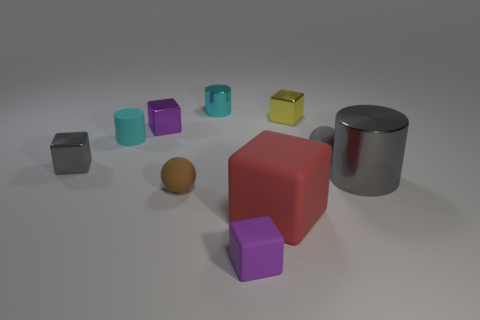Subtract all small cyan cylinders. How many cylinders are left? 1 Subtract all gray spheres. How many spheres are left? 1 Subtract all cylinders. How many objects are left? 7 Subtract 2 cylinders. How many cylinders are left? 1 Subtract 0 green balls. How many objects are left? 10 Subtract all brown spheres. Subtract all gray cylinders. How many spheres are left? 1 Subtract all cyan balls. How many gray cylinders are left? 1 Subtract all red rubber cubes. Subtract all yellow metal things. How many objects are left? 8 Add 8 tiny purple blocks. How many tiny purple blocks are left? 10 Add 3 cyan matte things. How many cyan matte things exist? 4 